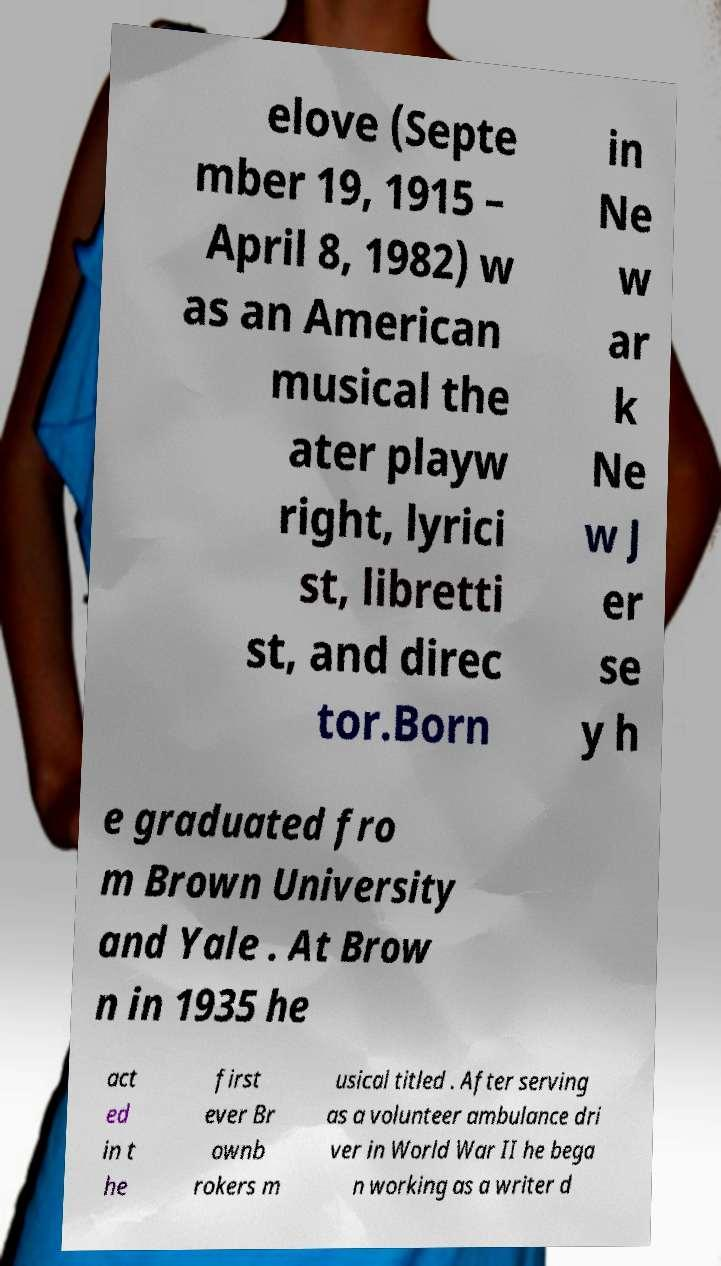There's text embedded in this image that I need extracted. Can you transcribe it verbatim? elove (Septe mber 19, 1915 – April 8, 1982) w as an American musical the ater playw right, lyrici st, libretti st, and direc tor.Born in Ne w ar k Ne w J er se y h e graduated fro m Brown University and Yale . At Brow n in 1935 he act ed in t he first ever Br ownb rokers m usical titled . After serving as a volunteer ambulance dri ver in World War II he bega n working as a writer d 